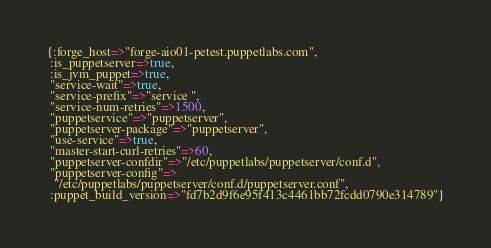Convert code to text. <code><loc_0><loc_0><loc_500><loc_500><_Ruby_>{:forge_host=>"forge-aio01-petest.puppetlabs.com",
 :is_puppetserver=>true,
 :is_jvm_puppet=>true,
 "service-wait"=>true,
 "service-prefix"=>"service ",
 "service-num-retries"=>1500,
 "puppetservice"=>"puppetserver",
 "puppetserver-package"=>"puppetserver",
 "use-service"=>true,
 "master-start-curl-retries"=>60,
 "puppetserver-confdir"=>"/etc/puppetlabs/puppetserver/conf.d",
 "puppetserver-config"=>
  "/etc/puppetlabs/puppetserver/conf.d/puppetserver.conf",
 :puppet_build_version=>"fd7b2d9f6e95f413c4461bb72fcdd0790e314789"}
</code> 